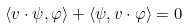Convert formula to latex. <formula><loc_0><loc_0><loc_500><loc_500>\langle v \cdot \psi , \varphi \rangle + \langle \psi , v \cdot \varphi \rangle = 0</formula> 